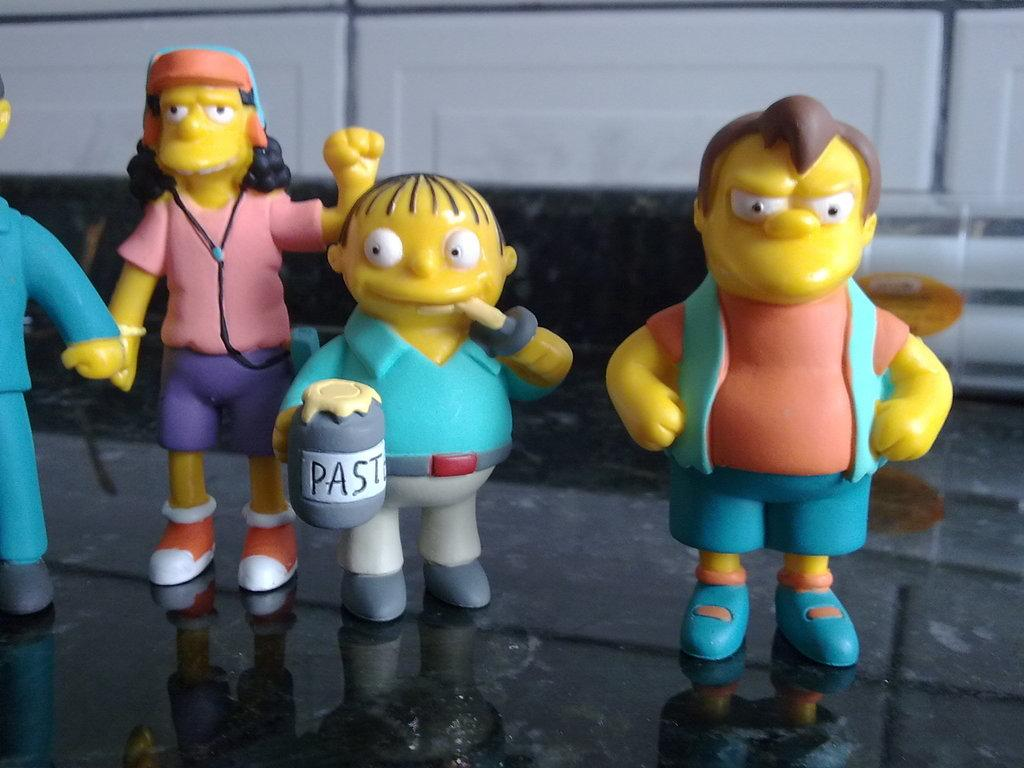What type of objects can be seen in the image? There are small toys in the image. Where are the toys placed? The toys are kept on a marble floor. Are there any straws or celery visible in the image? No, there are no straws or celery present in the image. 